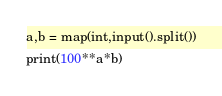<code> <loc_0><loc_0><loc_500><loc_500><_Python_>a,b = map(int,input().split())
print(100**a*b)</code> 